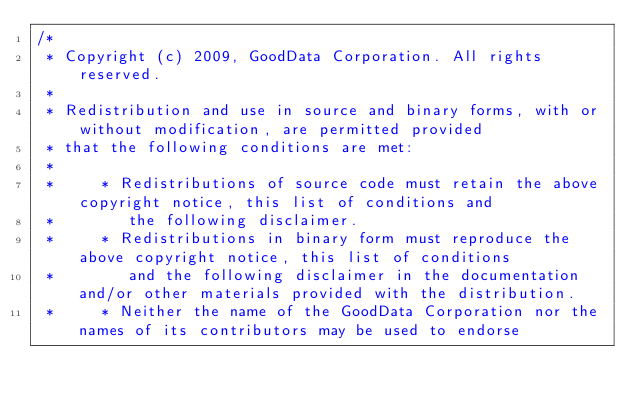Convert code to text. <code><loc_0><loc_0><loc_500><loc_500><_Java_>/*
 * Copyright (c) 2009, GoodData Corporation. All rights reserved.
 *
 * Redistribution and use in source and binary forms, with or without modification, are permitted provided
 * that the following conditions are met:
 *
 *     * Redistributions of source code must retain the above copyright notice, this list of conditions and
 *        the following disclaimer.
 *     * Redistributions in binary form must reproduce the above copyright notice, this list of conditions
 *        and the following disclaimer in the documentation and/or other materials provided with the distribution.
 *     * Neither the name of the GoodData Corporation nor the names of its contributors may be used to endorse</code> 